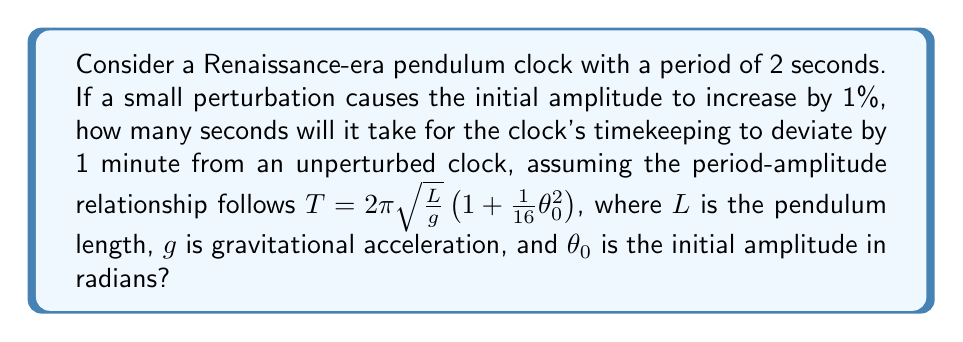Solve this math problem. 1. First, we need to calculate the difference in period caused by the perturbation:

   Original period: $T_1 = 2$ seconds
   Perturbed period: $T_2 = T_1 \cdot \sqrt{1.01} \approx 2.01$ seconds

   This is because the period is proportional to the square root of the amplitude.

2. Calculate the time difference accumulated per swing:
   $\Delta T = T_2 - T_1 \approx 0.01$ seconds

3. Calculate the number of swings needed to accumulate a 1-minute (60-second) difference:
   $N = \frac{60}{\Delta T} = \frac{60}{0.01} = 6000$ swings

4. Calculate the total time elapsed:
   $t = N \cdot T_2 = 6000 \cdot 2.01 = 12060$ seconds

Therefore, it will take approximately 12060 seconds for the perturbed clock to deviate by 1 minute from the unperturbed clock.
Answer: 12060 seconds 